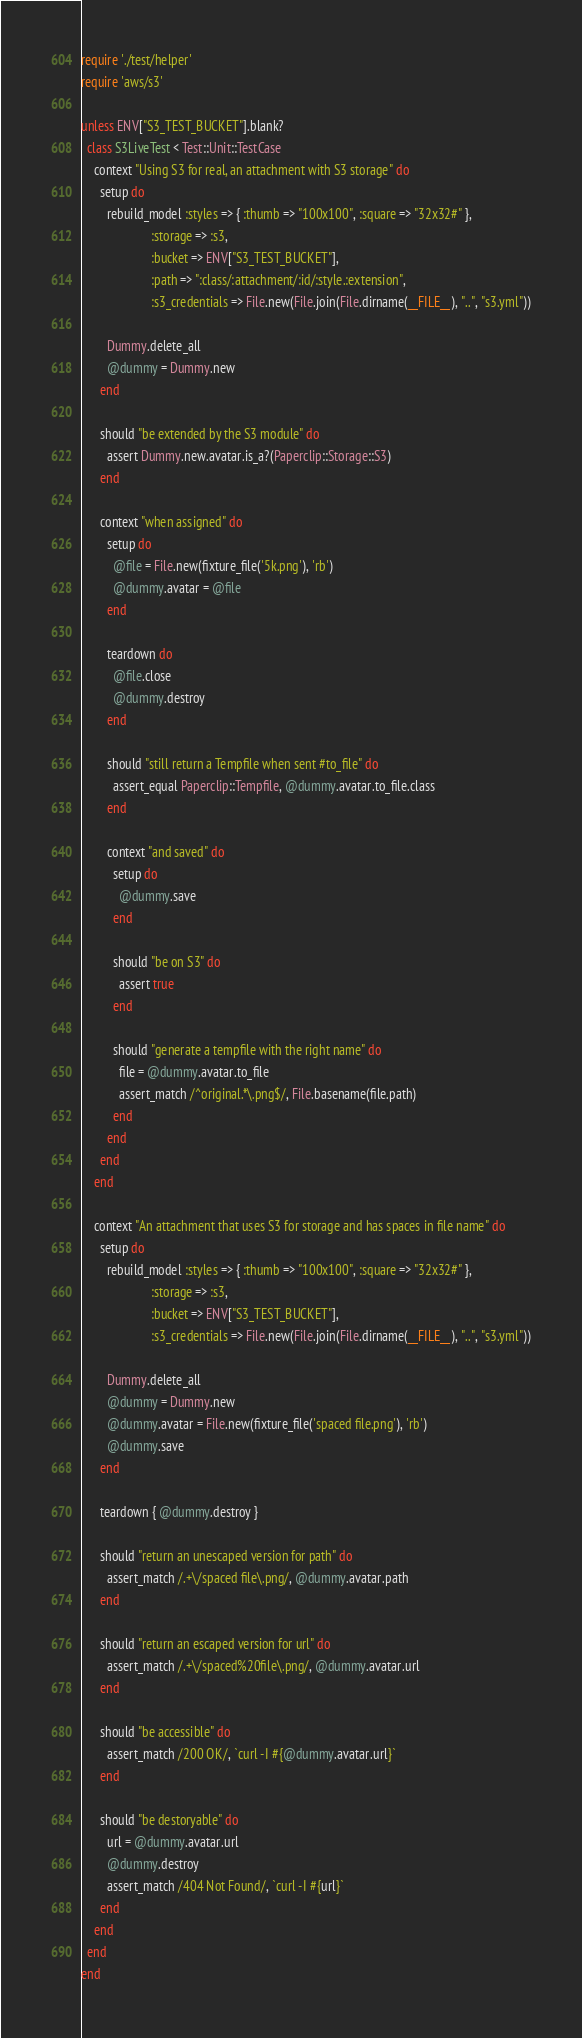<code> <loc_0><loc_0><loc_500><loc_500><_Ruby_>require './test/helper'
require 'aws/s3'

unless ENV["S3_TEST_BUCKET"].blank?
  class S3LiveTest < Test::Unit::TestCase
    context "Using S3 for real, an attachment with S3 storage" do
      setup do
        rebuild_model :styles => { :thumb => "100x100", :square => "32x32#" },
                      :storage => :s3,
                      :bucket => ENV["S3_TEST_BUCKET"],
                      :path => ":class/:attachment/:id/:style.:extension",
                      :s3_credentials => File.new(File.join(File.dirname(__FILE__), "..", "s3.yml"))

        Dummy.delete_all
        @dummy = Dummy.new
      end

      should "be extended by the S3 module" do
        assert Dummy.new.avatar.is_a?(Paperclip::Storage::S3)
      end

      context "when assigned" do
        setup do
          @file = File.new(fixture_file('5k.png'), 'rb')
          @dummy.avatar = @file
        end

        teardown do
          @file.close
          @dummy.destroy
        end

        should "still return a Tempfile when sent #to_file" do
          assert_equal Paperclip::Tempfile, @dummy.avatar.to_file.class
        end

        context "and saved" do
          setup do
            @dummy.save
          end

          should "be on S3" do
            assert true
          end

          should "generate a tempfile with the right name" do
            file = @dummy.avatar.to_file
            assert_match /^original.*\.png$/, File.basename(file.path)
          end
        end
      end
    end

    context "An attachment that uses S3 for storage and has spaces in file name" do
      setup do
        rebuild_model :styles => { :thumb => "100x100", :square => "32x32#" },
                      :storage => :s3,
                      :bucket => ENV["S3_TEST_BUCKET"],
                      :s3_credentials => File.new(File.join(File.dirname(__FILE__), "..", "s3.yml"))

        Dummy.delete_all
        @dummy = Dummy.new
        @dummy.avatar = File.new(fixture_file('spaced file.png'), 'rb')
        @dummy.save
      end

      teardown { @dummy.destroy }

      should "return an unescaped version for path" do
        assert_match /.+\/spaced file\.png/, @dummy.avatar.path
      end

      should "return an escaped version for url" do
        assert_match /.+\/spaced%20file\.png/, @dummy.avatar.url
      end

      should "be accessible" do
        assert_match /200 OK/, `curl -I #{@dummy.avatar.url}`
      end

      should "be destoryable" do
        url = @dummy.avatar.url
        @dummy.destroy
        assert_match /404 Not Found/, `curl -I #{url}`
      end
    end
  end
end
</code> 